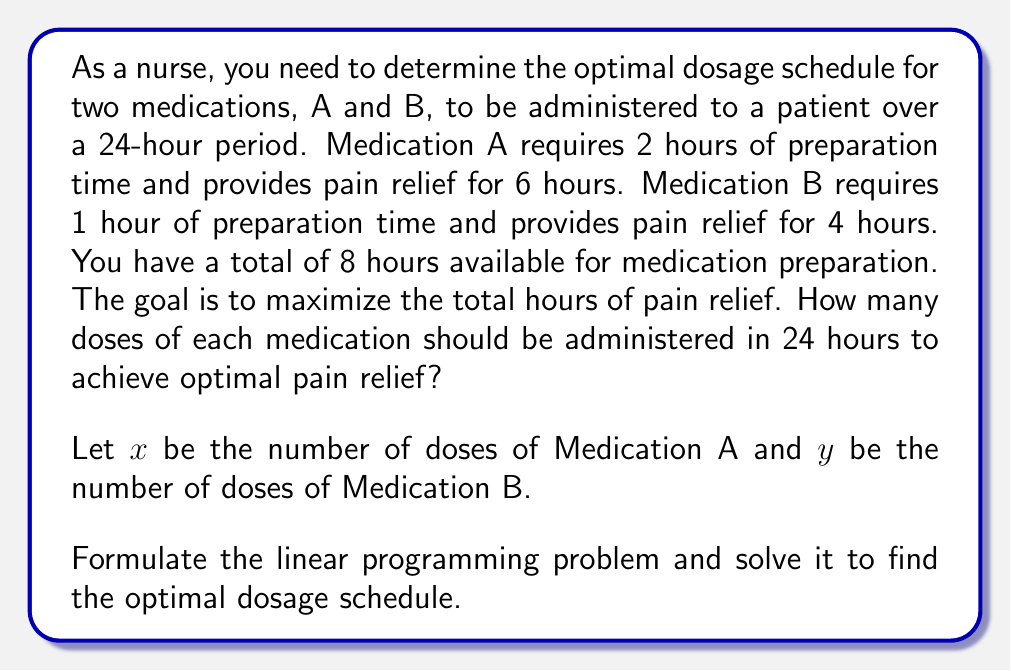Could you help me with this problem? To solve this problem, we'll follow these steps:

1. Formulate the linear programming problem:
   Objective function: Maximize $Z = 6x + 4y$ (total hours of pain relief)
   
   Constraints:
   - Preparation time: $2x + y \leq 8$ (total preparation time ≤ 8 hours)
   - Non-negativity: $x \geq 0$, $y \geq 0$
   - Integer constraint: $x$ and $y$ must be integers

2. Graph the feasible region:
   [asy]
   import geometry;
   
   size(200);
   
   real xmax = 5;
   real ymax = 10;
   
   draw((0,0)--(xmax,0)--(xmax,ymax)--(0,ymax)--cycle);
   draw((0,8)--(4,0), blue);
   
   label("$2x + y = 8$", (2,4), NE, blue);
   label("$x$", (xmax,0), S);
   label("$y$", (0,ymax), W);
   
   dot((0,8));
   dot((4,0));
   
   for (int i = 0; i <= xmax; ++i) {
     draw((i,0)--(i,0.1));
     label(string(i), (i,0), S);
   }
   
   for (int i = 0; i <= ymax; ++i) {
     draw((0,i)--(0.1,i));
     label(string(i), (0,i), W);
   }
   [/asy]

3. Identify the corner points of the feasible region:
   (0,0), (0,8), (4,0)

4. Evaluate the objective function at each corner point:
   $Z(0,0) = 0$
   $Z(0,8) = 32$
   $Z(4,0) = 24$

5. The maximum value occurs at (0,8), but we need to consider the integer constraint.

6. Check the nearby integer points:
   $Z(0,7) = 28$
   $Z(1,6) = 30$
   $Z(2,4) = 28$

7. The optimal integer solution is (1,6), meaning 1 dose of Medication A and 6 doses of Medication B.
Answer: 1 dose of Medication A and 6 doses of Medication B 